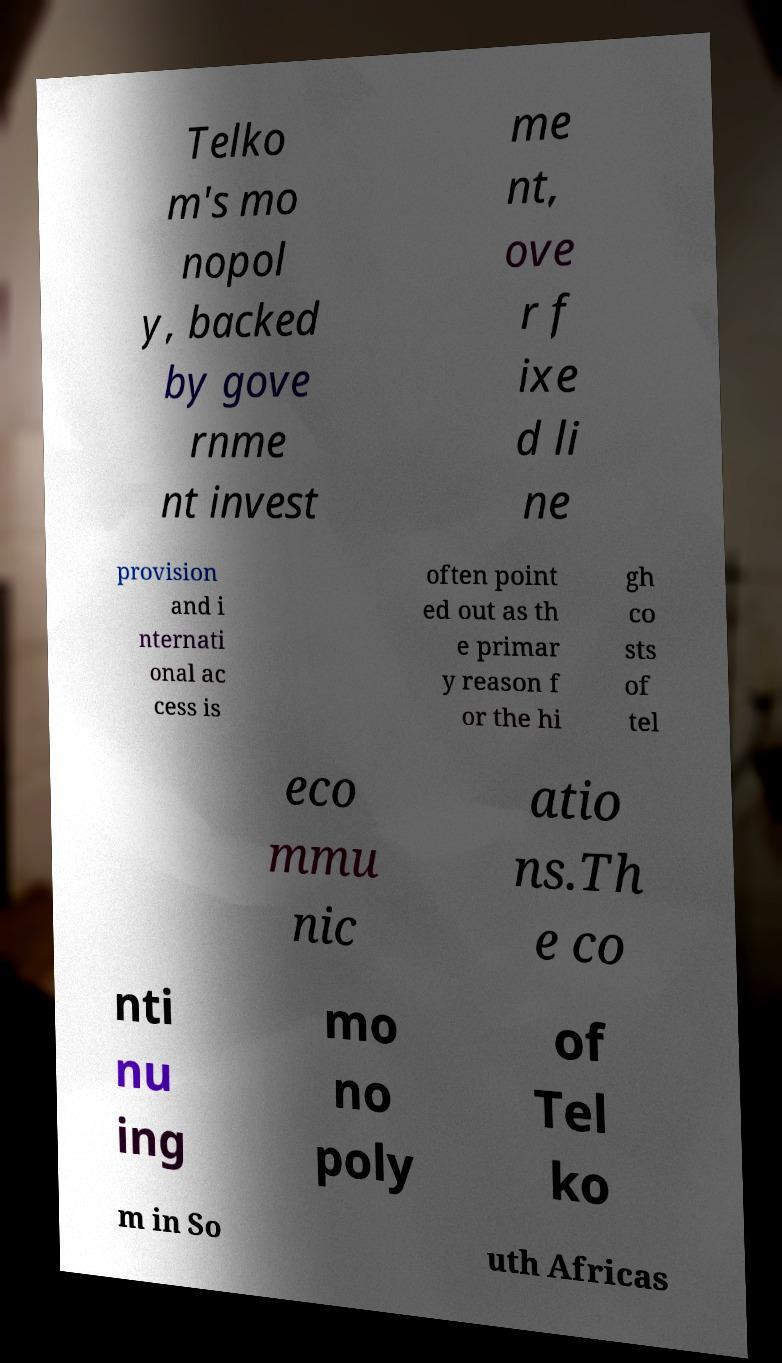For documentation purposes, I need the text within this image transcribed. Could you provide that? Telko m's mo nopol y, backed by gove rnme nt invest me nt, ove r f ixe d li ne provision and i nternati onal ac cess is often point ed out as th e primar y reason f or the hi gh co sts of tel eco mmu nic atio ns.Th e co nti nu ing mo no poly of Tel ko m in So uth Africas 